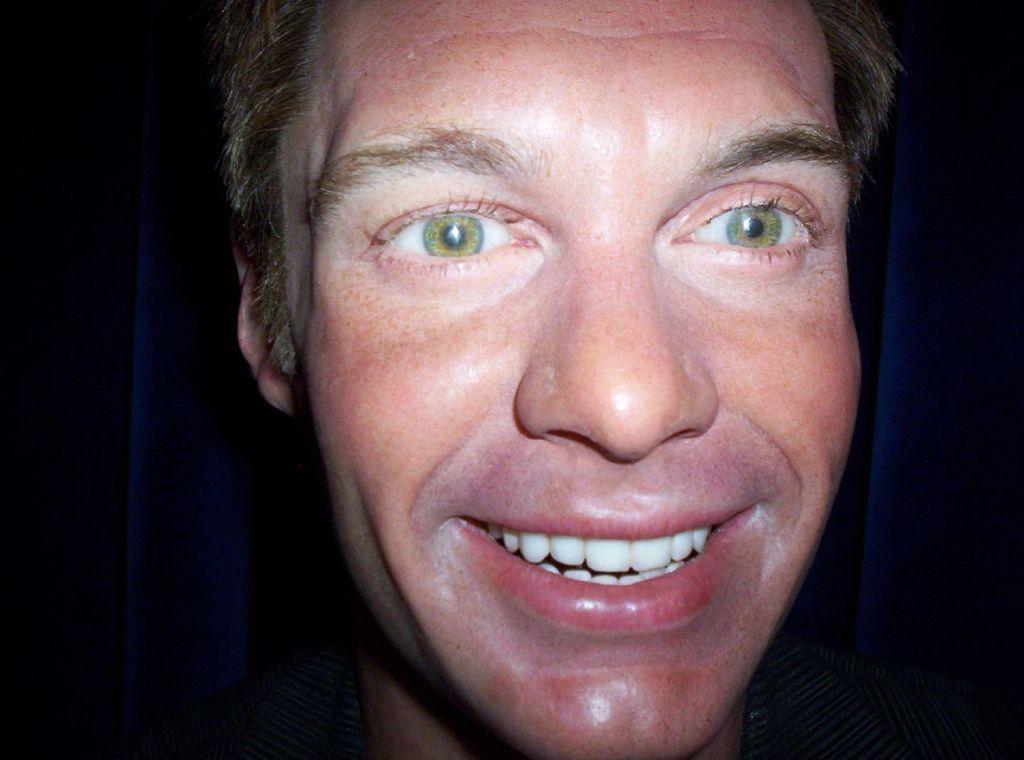What is the main subject of the image? There is a person's face in the image. Can you describe the background of the image? The background of the image is dark. Where is the cannon located in the image? There is no cannon present in the image. What type of shop can be seen in the background of the image? There is no shop visible in the image, as the background is dark. 